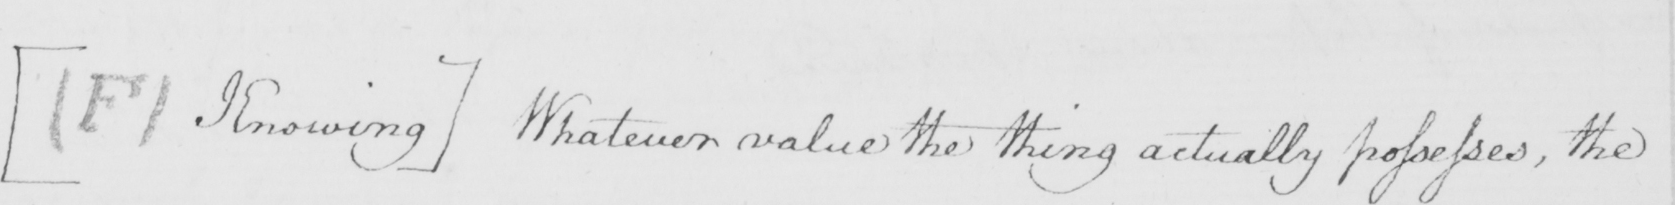Please transcribe the handwritten text in this image. [  ( F )  Knowing ]  Whatever value the thing actually possesses , the 